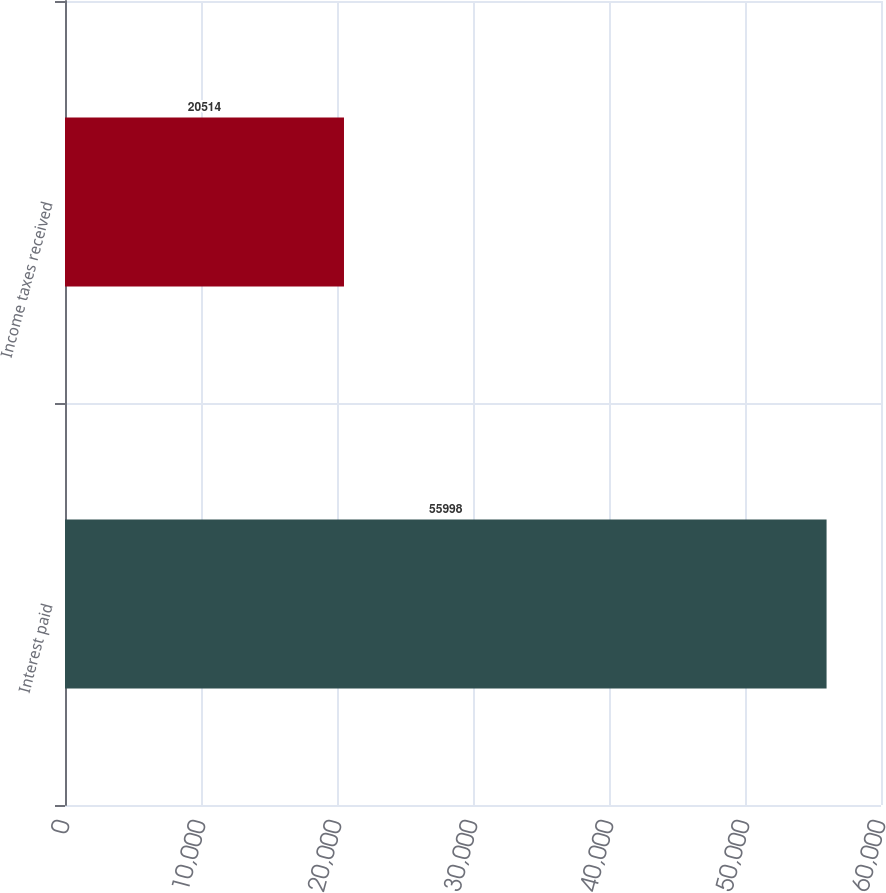Convert chart to OTSL. <chart><loc_0><loc_0><loc_500><loc_500><bar_chart><fcel>Interest paid<fcel>Income taxes received<nl><fcel>55998<fcel>20514<nl></chart> 